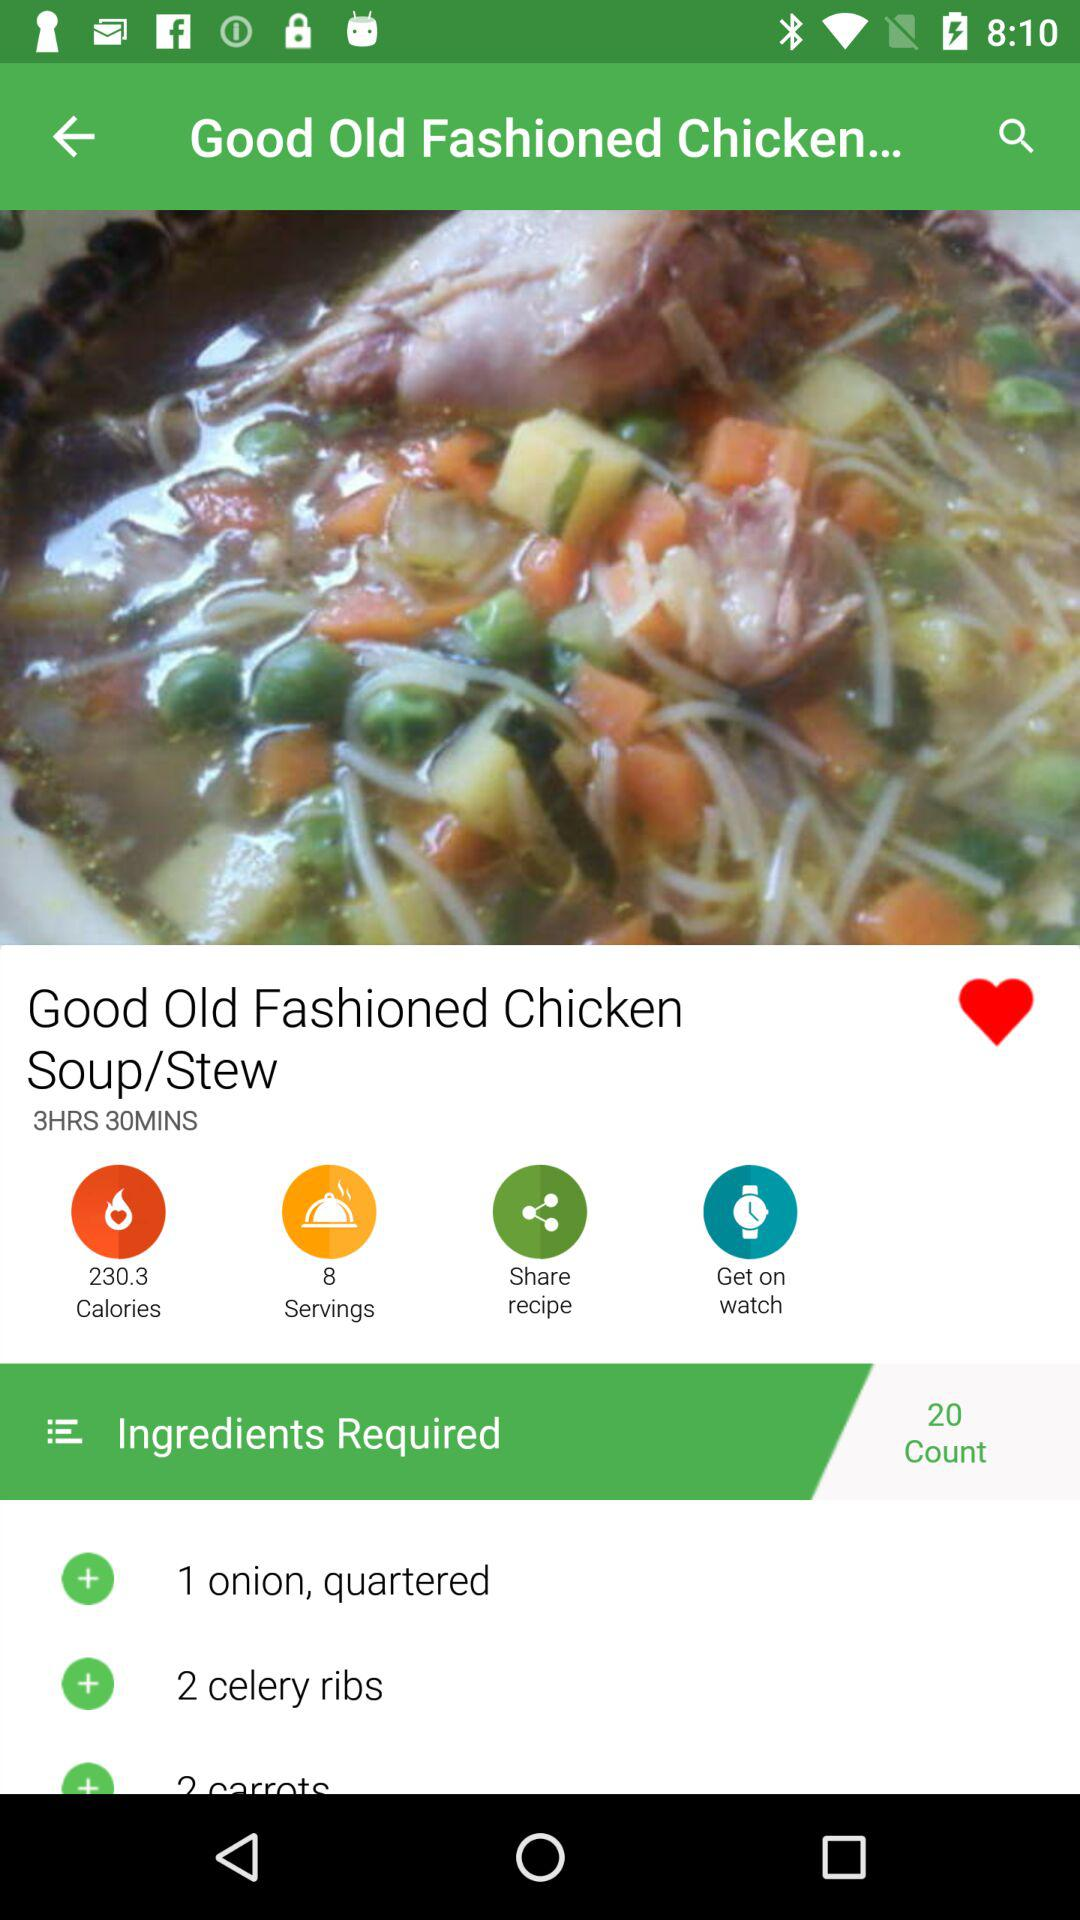What is the dish name? The dish name is "Good Old Fashioned Chicken Soup/Stew". 